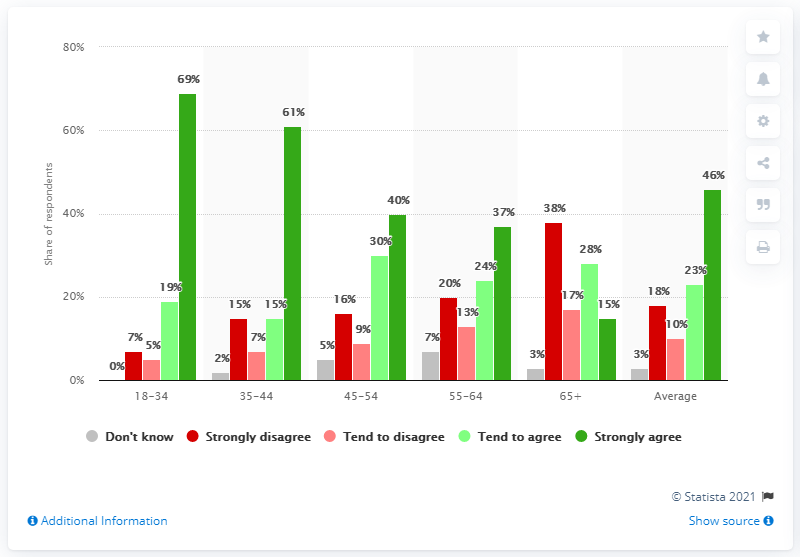Identify some key points in this picture. The average approval of homosexual marriage by all age groups was 69%. 